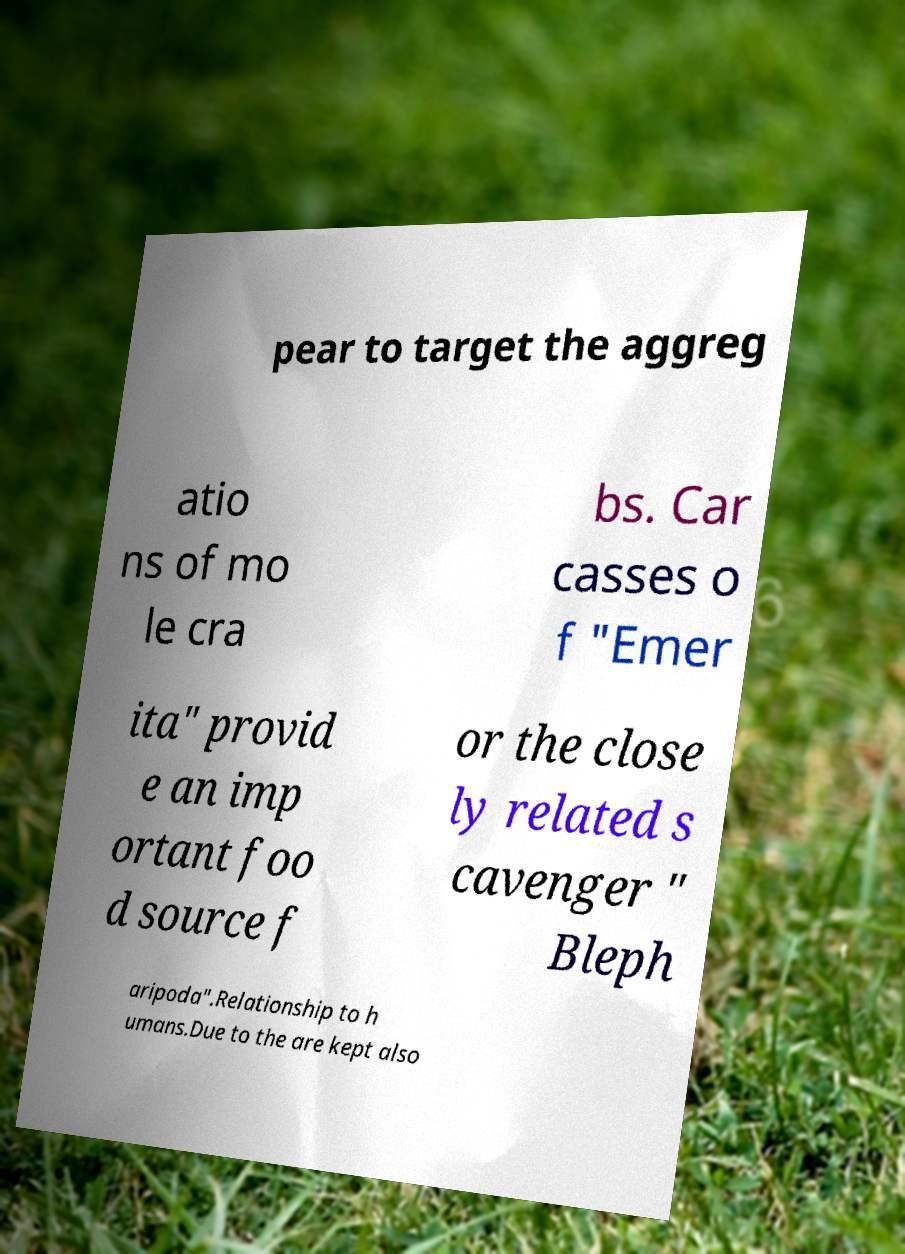There's text embedded in this image that I need extracted. Can you transcribe it verbatim? pear to target the aggreg atio ns of mo le cra bs. Car casses o f "Emer ita" provid e an imp ortant foo d source f or the close ly related s cavenger " Bleph aripoda".Relationship to h umans.Due to the are kept also 